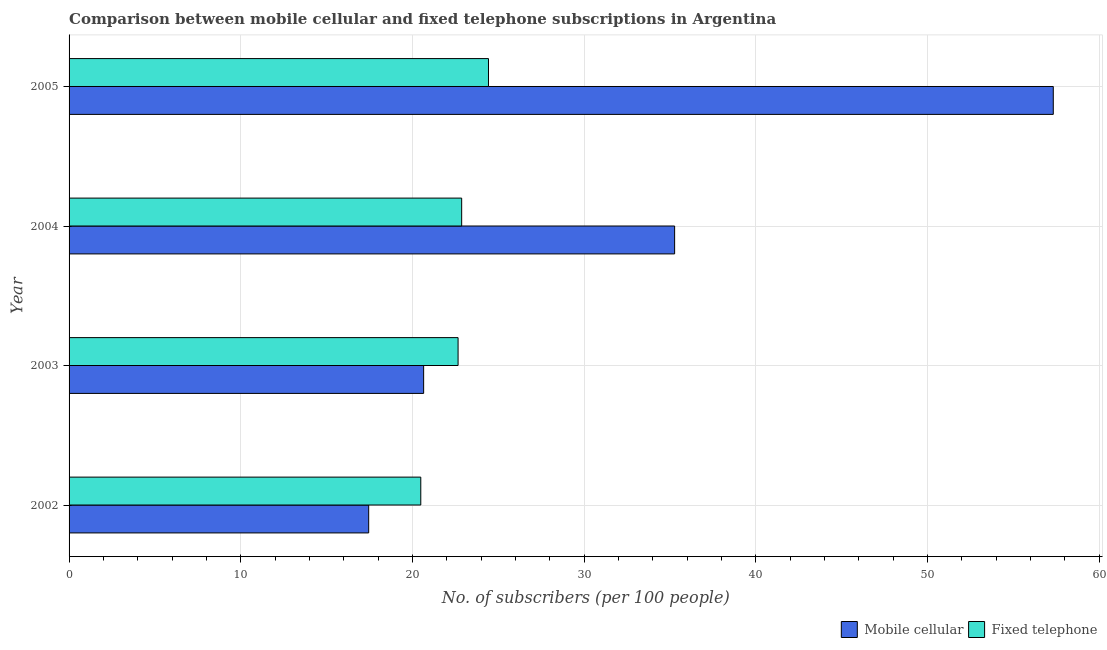How many different coloured bars are there?
Your response must be concise. 2. How many groups of bars are there?
Your answer should be very brief. 4. What is the label of the 3rd group of bars from the top?
Your answer should be very brief. 2003. What is the number of mobile cellular subscribers in 2003?
Provide a short and direct response. 20.65. Across all years, what is the maximum number of mobile cellular subscribers?
Your answer should be very brief. 57.33. Across all years, what is the minimum number of fixed telephone subscribers?
Your answer should be compact. 20.49. In which year was the number of mobile cellular subscribers minimum?
Ensure brevity in your answer.  2002. What is the total number of mobile cellular subscribers in the graph?
Your response must be concise. 130.71. What is the difference between the number of fixed telephone subscribers in 2002 and that in 2004?
Ensure brevity in your answer.  -2.38. What is the difference between the number of fixed telephone subscribers in 2002 and the number of mobile cellular subscribers in 2003?
Offer a terse response. -0.17. What is the average number of mobile cellular subscribers per year?
Your answer should be very brief. 32.68. In the year 2002, what is the difference between the number of fixed telephone subscribers and number of mobile cellular subscribers?
Ensure brevity in your answer.  3.04. What is the ratio of the number of mobile cellular subscribers in 2002 to that in 2003?
Your response must be concise. 0.84. Is the number of mobile cellular subscribers in 2004 less than that in 2005?
Offer a very short reply. Yes. Is the difference between the number of fixed telephone subscribers in 2004 and 2005 greater than the difference between the number of mobile cellular subscribers in 2004 and 2005?
Provide a short and direct response. Yes. What is the difference between the highest and the second highest number of fixed telephone subscribers?
Give a very brief answer. 1.56. What is the difference between the highest and the lowest number of mobile cellular subscribers?
Offer a very short reply. 39.88. What does the 1st bar from the top in 2003 represents?
Make the answer very short. Fixed telephone. What does the 1st bar from the bottom in 2004 represents?
Ensure brevity in your answer.  Mobile cellular. Does the graph contain any zero values?
Provide a short and direct response. No. Does the graph contain grids?
Offer a terse response. Yes. Where does the legend appear in the graph?
Offer a terse response. Bottom right. What is the title of the graph?
Provide a short and direct response. Comparison between mobile cellular and fixed telephone subscriptions in Argentina. Does "Pregnant women" appear as one of the legend labels in the graph?
Your answer should be compact. No. What is the label or title of the X-axis?
Your answer should be very brief. No. of subscribers (per 100 people). What is the label or title of the Y-axis?
Offer a very short reply. Year. What is the No. of subscribers (per 100 people) in Mobile cellular in 2002?
Ensure brevity in your answer.  17.45. What is the No. of subscribers (per 100 people) in Fixed telephone in 2002?
Your answer should be very brief. 20.49. What is the No. of subscribers (per 100 people) of Mobile cellular in 2003?
Give a very brief answer. 20.65. What is the No. of subscribers (per 100 people) of Fixed telephone in 2003?
Offer a terse response. 22.66. What is the No. of subscribers (per 100 people) of Mobile cellular in 2004?
Offer a very short reply. 35.27. What is the No. of subscribers (per 100 people) of Fixed telephone in 2004?
Offer a very short reply. 22.87. What is the No. of subscribers (per 100 people) in Mobile cellular in 2005?
Provide a succinct answer. 57.33. What is the No. of subscribers (per 100 people) of Fixed telephone in 2005?
Provide a short and direct response. 24.43. Across all years, what is the maximum No. of subscribers (per 100 people) of Mobile cellular?
Provide a succinct answer. 57.33. Across all years, what is the maximum No. of subscribers (per 100 people) in Fixed telephone?
Give a very brief answer. 24.43. Across all years, what is the minimum No. of subscribers (per 100 people) in Mobile cellular?
Give a very brief answer. 17.45. Across all years, what is the minimum No. of subscribers (per 100 people) in Fixed telephone?
Your response must be concise. 20.49. What is the total No. of subscribers (per 100 people) of Mobile cellular in the graph?
Ensure brevity in your answer.  130.71. What is the total No. of subscribers (per 100 people) in Fixed telephone in the graph?
Offer a terse response. 90.44. What is the difference between the No. of subscribers (per 100 people) in Mobile cellular in 2002 and that in 2003?
Your answer should be compact. -3.2. What is the difference between the No. of subscribers (per 100 people) of Fixed telephone in 2002 and that in 2003?
Offer a very short reply. -2.17. What is the difference between the No. of subscribers (per 100 people) of Mobile cellular in 2002 and that in 2004?
Make the answer very short. -17.82. What is the difference between the No. of subscribers (per 100 people) in Fixed telephone in 2002 and that in 2004?
Give a very brief answer. -2.38. What is the difference between the No. of subscribers (per 100 people) of Mobile cellular in 2002 and that in 2005?
Give a very brief answer. -39.88. What is the difference between the No. of subscribers (per 100 people) in Fixed telephone in 2002 and that in 2005?
Provide a succinct answer. -3.94. What is the difference between the No. of subscribers (per 100 people) in Mobile cellular in 2003 and that in 2004?
Give a very brief answer. -14.62. What is the difference between the No. of subscribers (per 100 people) in Fixed telephone in 2003 and that in 2004?
Offer a very short reply. -0.21. What is the difference between the No. of subscribers (per 100 people) of Mobile cellular in 2003 and that in 2005?
Your answer should be very brief. -36.68. What is the difference between the No. of subscribers (per 100 people) of Fixed telephone in 2003 and that in 2005?
Provide a short and direct response. -1.77. What is the difference between the No. of subscribers (per 100 people) of Mobile cellular in 2004 and that in 2005?
Ensure brevity in your answer.  -22.06. What is the difference between the No. of subscribers (per 100 people) of Fixed telephone in 2004 and that in 2005?
Provide a short and direct response. -1.56. What is the difference between the No. of subscribers (per 100 people) of Mobile cellular in 2002 and the No. of subscribers (per 100 people) of Fixed telephone in 2003?
Provide a short and direct response. -5.21. What is the difference between the No. of subscribers (per 100 people) in Mobile cellular in 2002 and the No. of subscribers (per 100 people) in Fixed telephone in 2004?
Your answer should be very brief. -5.42. What is the difference between the No. of subscribers (per 100 people) in Mobile cellular in 2002 and the No. of subscribers (per 100 people) in Fixed telephone in 2005?
Ensure brevity in your answer.  -6.98. What is the difference between the No. of subscribers (per 100 people) in Mobile cellular in 2003 and the No. of subscribers (per 100 people) in Fixed telephone in 2004?
Offer a terse response. -2.21. What is the difference between the No. of subscribers (per 100 people) of Mobile cellular in 2003 and the No. of subscribers (per 100 people) of Fixed telephone in 2005?
Ensure brevity in your answer.  -3.78. What is the difference between the No. of subscribers (per 100 people) of Mobile cellular in 2004 and the No. of subscribers (per 100 people) of Fixed telephone in 2005?
Give a very brief answer. 10.84. What is the average No. of subscribers (per 100 people) in Mobile cellular per year?
Your answer should be compact. 32.68. What is the average No. of subscribers (per 100 people) in Fixed telephone per year?
Your answer should be very brief. 22.61. In the year 2002, what is the difference between the No. of subscribers (per 100 people) in Mobile cellular and No. of subscribers (per 100 people) in Fixed telephone?
Offer a terse response. -3.03. In the year 2003, what is the difference between the No. of subscribers (per 100 people) in Mobile cellular and No. of subscribers (per 100 people) in Fixed telephone?
Make the answer very short. -2.01. In the year 2004, what is the difference between the No. of subscribers (per 100 people) in Mobile cellular and No. of subscribers (per 100 people) in Fixed telephone?
Provide a short and direct response. 12.4. In the year 2005, what is the difference between the No. of subscribers (per 100 people) in Mobile cellular and No. of subscribers (per 100 people) in Fixed telephone?
Your response must be concise. 32.9. What is the ratio of the No. of subscribers (per 100 people) in Mobile cellular in 2002 to that in 2003?
Ensure brevity in your answer.  0.84. What is the ratio of the No. of subscribers (per 100 people) in Fixed telephone in 2002 to that in 2003?
Your response must be concise. 0.9. What is the ratio of the No. of subscribers (per 100 people) of Mobile cellular in 2002 to that in 2004?
Your answer should be compact. 0.49. What is the ratio of the No. of subscribers (per 100 people) of Fixed telephone in 2002 to that in 2004?
Ensure brevity in your answer.  0.9. What is the ratio of the No. of subscribers (per 100 people) in Mobile cellular in 2002 to that in 2005?
Provide a succinct answer. 0.3. What is the ratio of the No. of subscribers (per 100 people) of Fixed telephone in 2002 to that in 2005?
Offer a terse response. 0.84. What is the ratio of the No. of subscribers (per 100 people) in Mobile cellular in 2003 to that in 2004?
Your answer should be very brief. 0.59. What is the ratio of the No. of subscribers (per 100 people) of Fixed telephone in 2003 to that in 2004?
Ensure brevity in your answer.  0.99. What is the ratio of the No. of subscribers (per 100 people) of Mobile cellular in 2003 to that in 2005?
Provide a short and direct response. 0.36. What is the ratio of the No. of subscribers (per 100 people) in Fixed telephone in 2003 to that in 2005?
Offer a terse response. 0.93. What is the ratio of the No. of subscribers (per 100 people) of Mobile cellular in 2004 to that in 2005?
Make the answer very short. 0.62. What is the ratio of the No. of subscribers (per 100 people) of Fixed telephone in 2004 to that in 2005?
Ensure brevity in your answer.  0.94. What is the difference between the highest and the second highest No. of subscribers (per 100 people) in Mobile cellular?
Your answer should be very brief. 22.06. What is the difference between the highest and the second highest No. of subscribers (per 100 people) of Fixed telephone?
Your answer should be compact. 1.56. What is the difference between the highest and the lowest No. of subscribers (per 100 people) in Mobile cellular?
Give a very brief answer. 39.88. What is the difference between the highest and the lowest No. of subscribers (per 100 people) of Fixed telephone?
Keep it short and to the point. 3.94. 